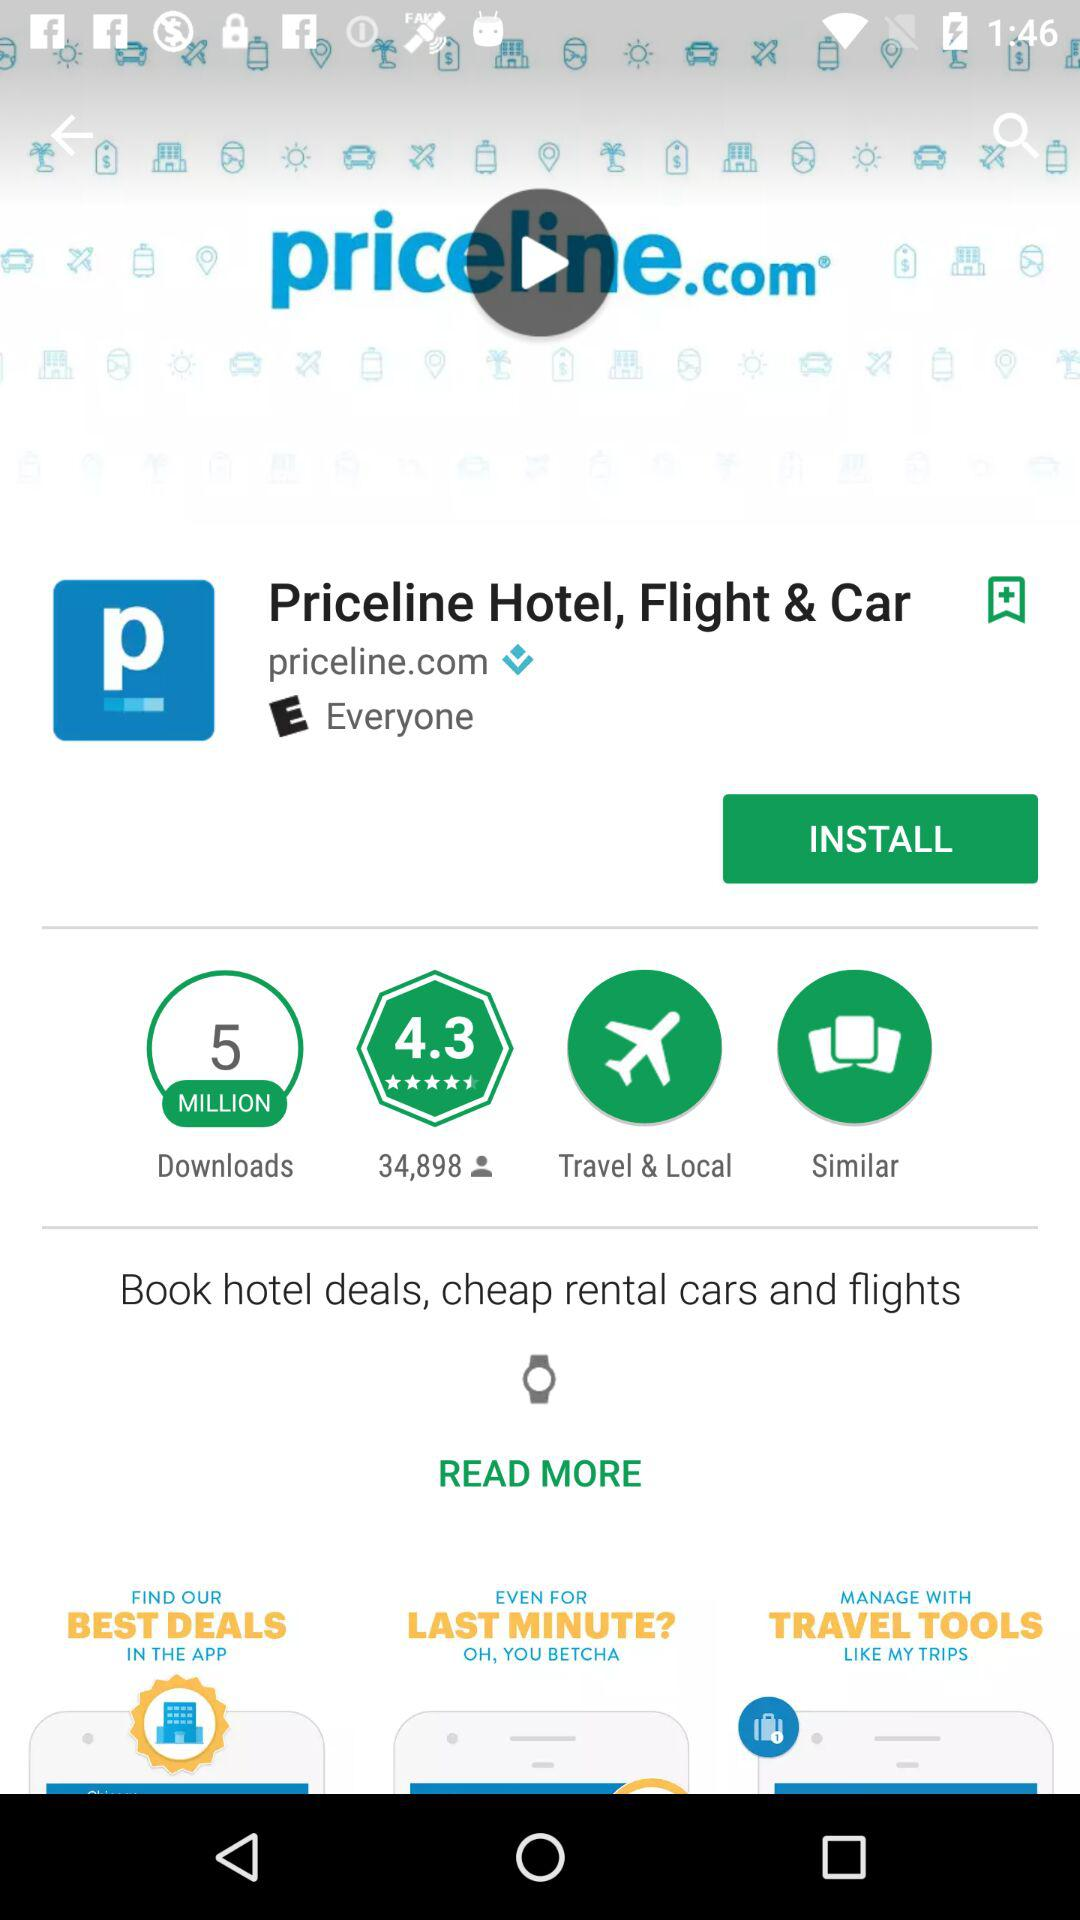What is the rating of the application "Princeline Hotel, Flight & Car"? The rating is 4.3 stars. 